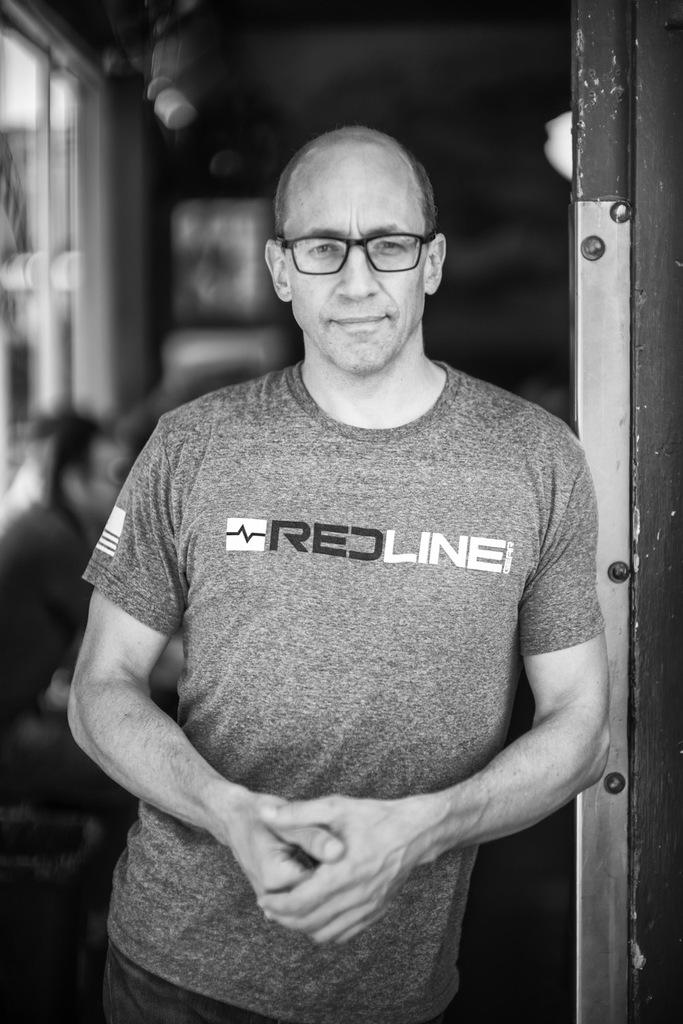What can be seen in the image? There is a person in the image. Can you describe the person's clothing? The person is wearing a t-shirt. What accessory is the person wearing? The person is wearing spectacles. What is the person's posture in the image? The person is standing. What can be seen in the background of the image? There is a group of people and a window in the background of the image. What type of cactus can be seen in the image? There is no cactus present in the image. What action is the police officer taking in the image? There is no police officer or action present in the image. 